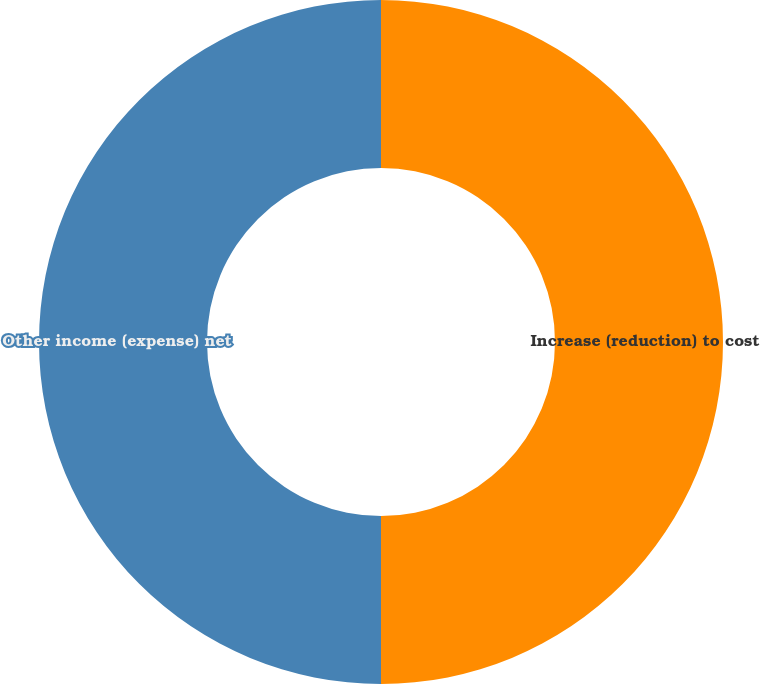Convert chart to OTSL. <chart><loc_0><loc_0><loc_500><loc_500><pie_chart><fcel>Increase (reduction) to cost<fcel>Other income (expense) net<nl><fcel>50.0%<fcel>50.0%<nl></chart> 